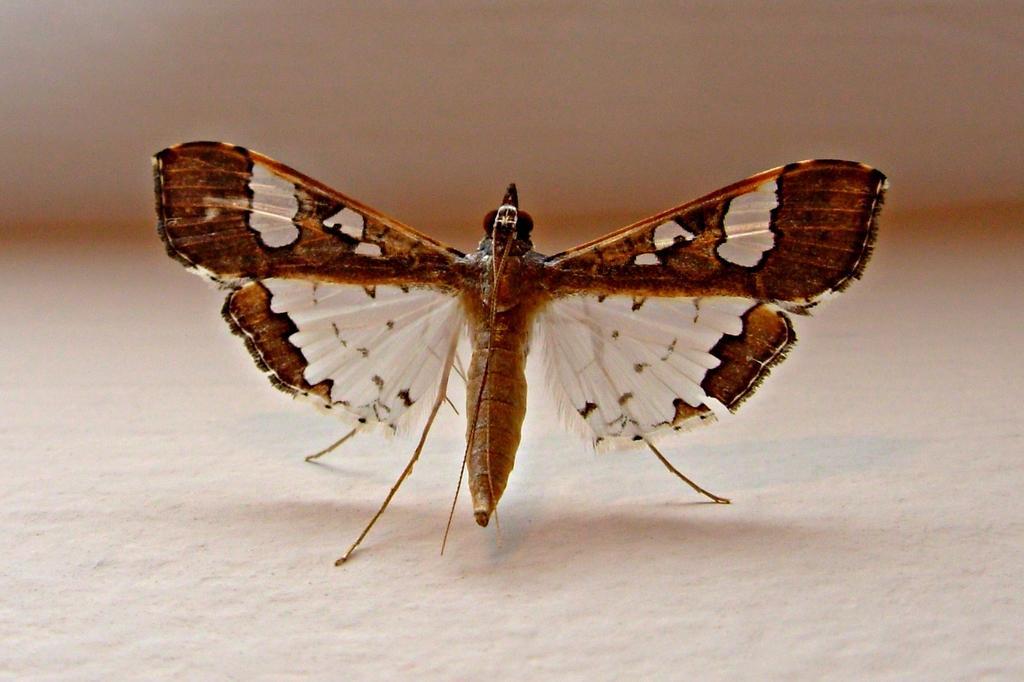How would you summarize this image in a sentence or two? In the center of the image, we can see a butterfly on the surface. 